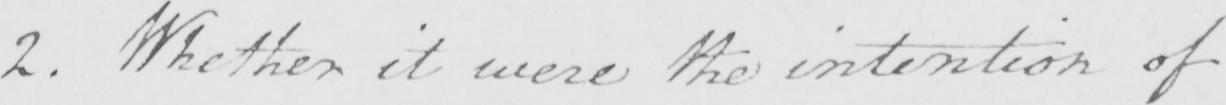What does this handwritten line say? 2 . Whether it were the intention of 